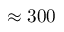Convert formula to latex. <formula><loc_0><loc_0><loc_500><loc_500>\approx 3 0 0</formula> 